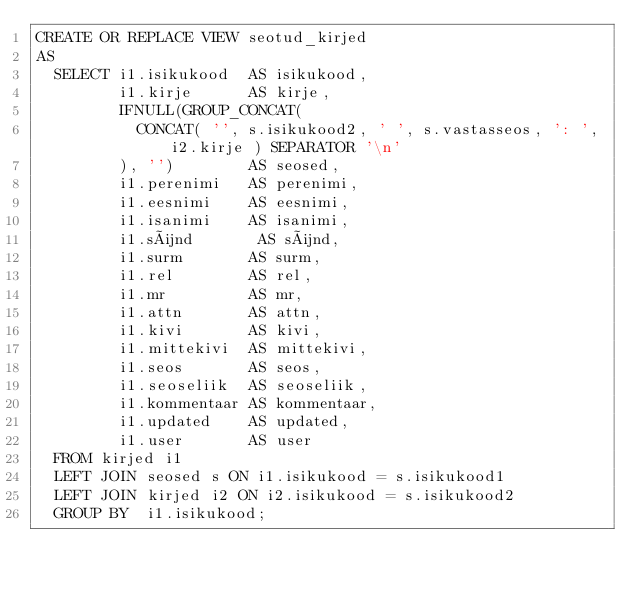<code> <loc_0><loc_0><loc_500><loc_500><_SQL_>CREATE OR REPLACE VIEW seotud_kirjed
AS 
  SELECT i1.isikukood  AS isikukood,
         i1.kirje      AS kirje,
         IFNULL(GROUP_CONCAT(
           CONCAT( '', s.isikukood2, ' ', s.vastasseos, ': ', i2.kirje ) SEPARATOR '\n'
         ), '')        AS seosed,
         i1.perenimi   AS perenimi,
         i1.eesnimi    AS eesnimi,
         i1.isanimi    AS isanimi,
         i1.sünd       AS sünd,
         i1.surm       AS surm,
         i1.rel        AS rel,
         i1.mr         AS mr,
         i1.attn       AS attn,
         i1.kivi       AS kivi,
         i1.mittekivi  AS mittekivi,
         i1.seos       AS seos,
         i1.seoseliik  AS seoseliik,
         i1.kommentaar AS kommentaar,
         i1.updated    AS updated,
         i1.user       AS user
  FROM kirjed i1 
  LEFT JOIN seosed s ON i1.isikukood = s.isikukood1
  LEFT JOIN kirjed i2 ON i2.isikukood = s.isikukood2
  GROUP BY  i1.isikukood;</code> 